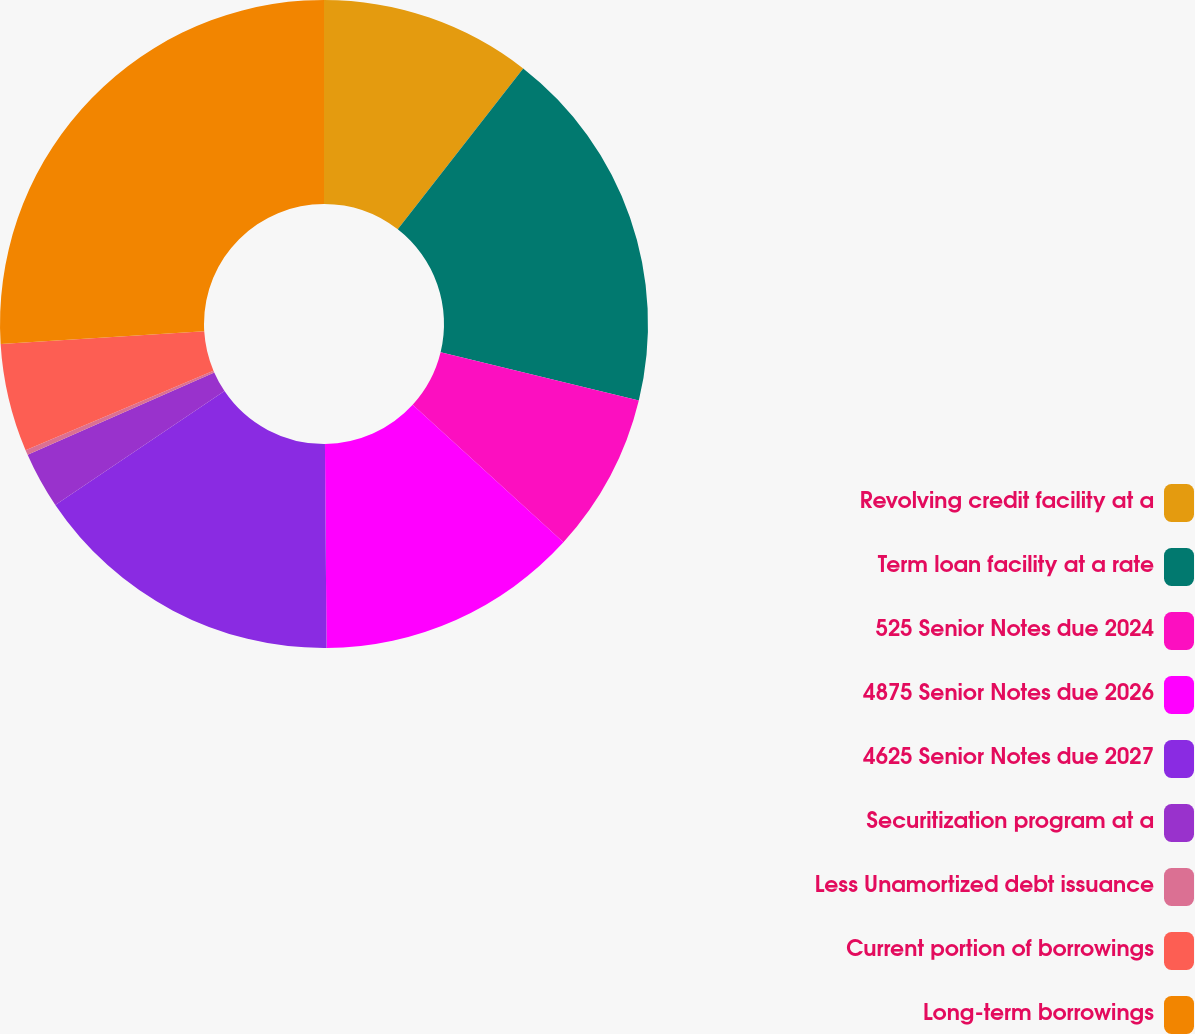Convert chart to OTSL. <chart><loc_0><loc_0><loc_500><loc_500><pie_chart><fcel>Revolving credit facility at a<fcel>Term loan facility at a rate<fcel>525 Senior Notes due 2024<fcel>4875 Senior Notes due 2026<fcel>4625 Senior Notes due 2027<fcel>Securitization program at a<fcel>Less Unamortized debt issuance<fcel>Current portion of borrowings<fcel>Long-term borrowings<nl><fcel>10.54%<fcel>18.26%<fcel>7.97%<fcel>13.11%<fcel>15.69%<fcel>2.82%<fcel>0.25%<fcel>5.39%<fcel>25.98%<nl></chart> 